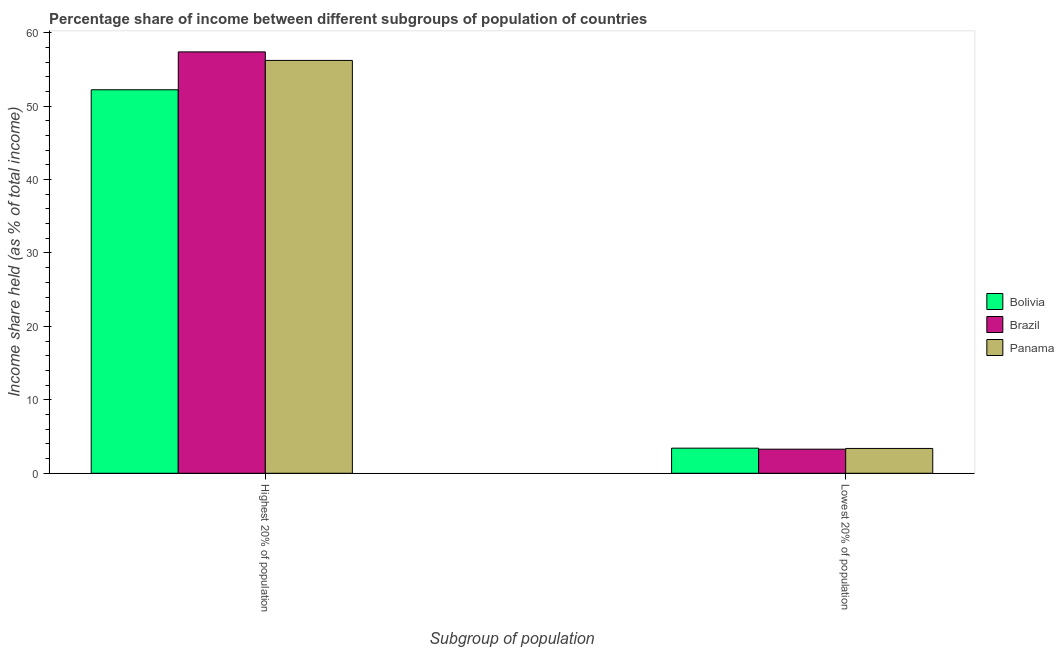Are the number of bars per tick equal to the number of legend labels?
Keep it short and to the point. Yes. Are the number of bars on each tick of the X-axis equal?
Keep it short and to the point. Yes. How many bars are there on the 2nd tick from the right?
Your response must be concise. 3. What is the label of the 1st group of bars from the left?
Offer a very short reply. Highest 20% of population. What is the income share held by lowest 20% of the population in Brazil?
Offer a very short reply. 3.28. Across all countries, what is the maximum income share held by highest 20% of the population?
Ensure brevity in your answer.  57.39. Across all countries, what is the minimum income share held by highest 20% of the population?
Keep it short and to the point. 52.23. In which country was the income share held by lowest 20% of the population maximum?
Offer a very short reply. Bolivia. What is the total income share held by lowest 20% of the population in the graph?
Offer a terse response. 10.08. What is the difference between the income share held by lowest 20% of the population in Panama and that in Bolivia?
Your answer should be compact. -0.04. What is the difference between the income share held by lowest 20% of the population in Bolivia and the income share held by highest 20% of the population in Panama?
Your answer should be very brief. -52.81. What is the average income share held by highest 20% of the population per country?
Offer a very short reply. 55.28. What is the difference between the income share held by lowest 20% of the population and income share held by highest 20% of the population in Brazil?
Your answer should be compact. -54.11. What is the ratio of the income share held by lowest 20% of the population in Bolivia to that in Brazil?
Offer a terse response. 1.04. In how many countries, is the income share held by highest 20% of the population greater than the average income share held by highest 20% of the population taken over all countries?
Make the answer very short. 2. What does the 2nd bar from the left in Lowest 20% of population represents?
Your answer should be very brief. Brazil. What does the 1st bar from the right in Highest 20% of population represents?
Your answer should be very brief. Panama. How many bars are there?
Your answer should be very brief. 6. How many countries are there in the graph?
Offer a very short reply. 3. Does the graph contain grids?
Offer a very short reply. No. Where does the legend appear in the graph?
Your answer should be compact. Center right. How many legend labels are there?
Provide a short and direct response. 3. What is the title of the graph?
Make the answer very short. Percentage share of income between different subgroups of population of countries. Does "Brunei Darussalam" appear as one of the legend labels in the graph?
Provide a succinct answer. No. What is the label or title of the X-axis?
Provide a short and direct response. Subgroup of population. What is the label or title of the Y-axis?
Offer a terse response. Income share held (as % of total income). What is the Income share held (as % of total income) of Bolivia in Highest 20% of population?
Offer a terse response. 52.23. What is the Income share held (as % of total income) in Brazil in Highest 20% of population?
Give a very brief answer. 57.39. What is the Income share held (as % of total income) of Panama in Highest 20% of population?
Give a very brief answer. 56.23. What is the Income share held (as % of total income) in Bolivia in Lowest 20% of population?
Offer a very short reply. 3.42. What is the Income share held (as % of total income) of Brazil in Lowest 20% of population?
Provide a succinct answer. 3.28. What is the Income share held (as % of total income) of Panama in Lowest 20% of population?
Your answer should be compact. 3.38. Across all Subgroup of population, what is the maximum Income share held (as % of total income) in Bolivia?
Make the answer very short. 52.23. Across all Subgroup of population, what is the maximum Income share held (as % of total income) in Brazil?
Make the answer very short. 57.39. Across all Subgroup of population, what is the maximum Income share held (as % of total income) of Panama?
Your answer should be compact. 56.23. Across all Subgroup of population, what is the minimum Income share held (as % of total income) of Bolivia?
Provide a succinct answer. 3.42. Across all Subgroup of population, what is the minimum Income share held (as % of total income) of Brazil?
Offer a very short reply. 3.28. Across all Subgroup of population, what is the minimum Income share held (as % of total income) in Panama?
Your answer should be compact. 3.38. What is the total Income share held (as % of total income) of Bolivia in the graph?
Offer a very short reply. 55.65. What is the total Income share held (as % of total income) of Brazil in the graph?
Provide a short and direct response. 60.67. What is the total Income share held (as % of total income) in Panama in the graph?
Offer a terse response. 59.61. What is the difference between the Income share held (as % of total income) in Bolivia in Highest 20% of population and that in Lowest 20% of population?
Your response must be concise. 48.81. What is the difference between the Income share held (as % of total income) of Brazil in Highest 20% of population and that in Lowest 20% of population?
Offer a terse response. 54.11. What is the difference between the Income share held (as % of total income) in Panama in Highest 20% of population and that in Lowest 20% of population?
Your answer should be compact. 52.85. What is the difference between the Income share held (as % of total income) in Bolivia in Highest 20% of population and the Income share held (as % of total income) in Brazil in Lowest 20% of population?
Keep it short and to the point. 48.95. What is the difference between the Income share held (as % of total income) in Bolivia in Highest 20% of population and the Income share held (as % of total income) in Panama in Lowest 20% of population?
Your answer should be compact. 48.85. What is the difference between the Income share held (as % of total income) of Brazil in Highest 20% of population and the Income share held (as % of total income) of Panama in Lowest 20% of population?
Offer a terse response. 54.01. What is the average Income share held (as % of total income) in Bolivia per Subgroup of population?
Your answer should be very brief. 27.82. What is the average Income share held (as % of total income) of Brazil per Subgroup of population?
Make the answer very short. 30.34. What is the average Income share held (as % of total income) in Panama per Subgroup of population?
Offer a terse response. 29.8. What is the difference between the Income share held (as % of total income) of Bolivia and Income share held (as % of total income) of Brazil in Highest 20% of population?
Give a very brief answer. -5.16. What is the difference between the Income share held (as % of total income) of Brazil and Income share held (as % of total income) of Panama in Highest 20% of population?
Offer a terse response. 1.16. What is the difference between the Income share held (as % of total income) in Bolivia and Income share held (as % of total income) in Brazil in Lowest 20% of population?
Offer a terse response. 0.14. What is the difference between the Income share held (as % of total income) of Bolivia and Income share held (as % of total income) of Panama in Lowest 20% of population?
Give a very brief answer. 0.04. What is the difference between the Income share held (as % of total income) of Brazil and Income share held (as % of total income) of Panama in Lowest 20% of population?
Provide a short and direct response. -0.1. What is the ratio of the Income share held (as % of total income) of Bolivia in Highest 20% of population to that in Lowest 20% of population?
Ensure brevity in your answer.  15.27. What is the ratio of the Income share held (as % of total income) in Brazil in Highest 20% of population to that in Lowest 20% of population?
Keep it short and to the point. 17.5. What is the ratio of the Income share held (as % of total income) in Panama in Highest 20% of population to that in Lowest 20% of population?
Offer a terse response. 16.64. What is the difference between the highest and the second highest Income share held (as % of total income) of Bolivia?
Make the answer very short. 48.81. What is the difference between the highest and the second highest Income share held (as % of total income) of Brazil?
Offer a very short reply. 54.11. What is the difference between the highest and the second highest Income share held (as % of total income) in Panama?
Give a very brief answer. 52.85. What is the difference between the highest and the lowest Income share held (as % of total income) of Bolivia?
Provide a short and direct response. 48.81. What is the difference between the highest and the lowest Income share held (as % of total income) of Brazil?
Your response must be concise. 54.11. What is the difference between the highest and the lowest Income share held (as % of total income) of Panama?
Offer a very short reply. 52.85. 